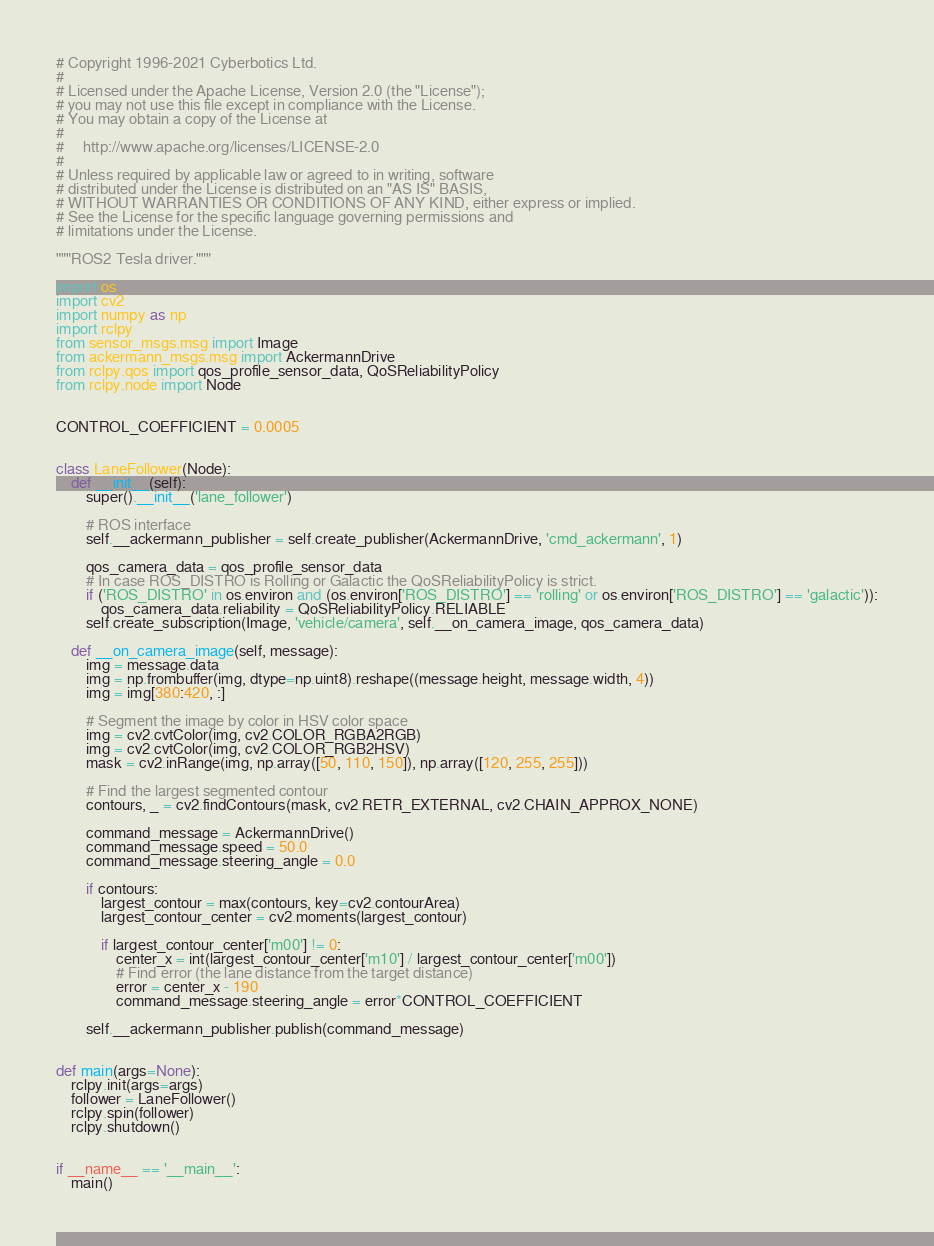Convert code to text. <code><loc_0><loc_0><loc_500><loc_500><_Python_># Copyright 1996-2021 Cyberbotics Ltd.
#
# Licensed under the Apache License, Version 2.0 (the "License");
# you may not use this file except in compliance with the License.
# You may obtain a copy of the License at
#
#     http://www.apache.org/licenses/LICENSE-2.0
#
# Unless required by applicable law or agreed to in writing, software
# distributed under the License is distributed on an "AS IS" BASIS,
# WITHOUT WARRANTIES OR CONDITIONS OF ANY KIND, either express or implied.
# See the License for the specific language governing permissions and
# limitations under the License.

"""ROS2 Tesla driver."""

import os
import cv2
import numpy as np
import rclpy
from sensor_msgs.msg import Image
from ackermann_msgs.msg import AckermannDrive
from rclpy.qos import qos_profile_sensor_data, QoSReliabilityPolicy
from rclpy.node import Node


CONTROL_COEFFICIENT = 0.0005


class LaneFollower(Node):
    def __init__(self):
        super().__init__('lane_follower')

        # ROS interface
        self.__ackermann_publisher = self.create_publisher(AckermannDrive, 'cmd_ackermann', 1)

        qos_camera_data = qos_profile_sensor_data
        # In case ROS_DISTRO is Rolling or Galactic the QoSReliabilityPolicy is strict.
        if ('ROS_DISTRO' in os.environ and (os.environ['ROS_DISTRO'] == 'rolling' or os.environ['ROS_DISTRO'] == 'galactic')):
            qos_camera_data.reliability = QoSReliabilityPolicy.RELIABLE
        self.create_subscription(Image, 'vehicle/camera', self.__on_camera_image, qos_camera_data)

    def __on_camera_image(self, message):
        img = message.data
        img = np.frombuffer(img, dtype=np.uint8).reshape((message.height, message.width, 4))
        img = img[380:420, :]

        # Segment the image by color in HSV color space
        img = cv2.cvtColor(img, cv2.COLOR_RGBA2RGB)
        img = cv2.cvtColor(img, cv2.COLOR_RGB2HSV)
        mask = cv2.inRange(img, np.array([50, 110, 150]), np.array([120, 255, 255]))

        # Find the largest segmented contour
        contours, _ = cv2.findContours(mask, cv2.RETR_EXTERNAL, cv2.CHAIN_APPROX_NONE)

        command_message = AckermannDrive()
        command_message.speed = 50.0
        command_message.steering_angle = 0.0

        if contours:
            largest_contour = max(contours, key=cv2.contourArea)
            largest_contour_center = cv2.moments(largest_contour)

            if largest_contour_center['m00'] != 0:
                center_x = int(largest_contour_center['m10'] / largest_contour_center['m00'])
                # Find error (the lane distance from the target distance)
                error = center_x - 190
                command_message.steering_angle = error*CONTROL_COEFFICIENT

        self.__ackermann_publisher.publish(command_message)


def main(args=None):
    rclpy.init(args=args)
    follower = LaneFollower()
    rclpy.spin(follower)
    rclpy.shutdown()


if __name__ == '__main__':
    main()
</code> 